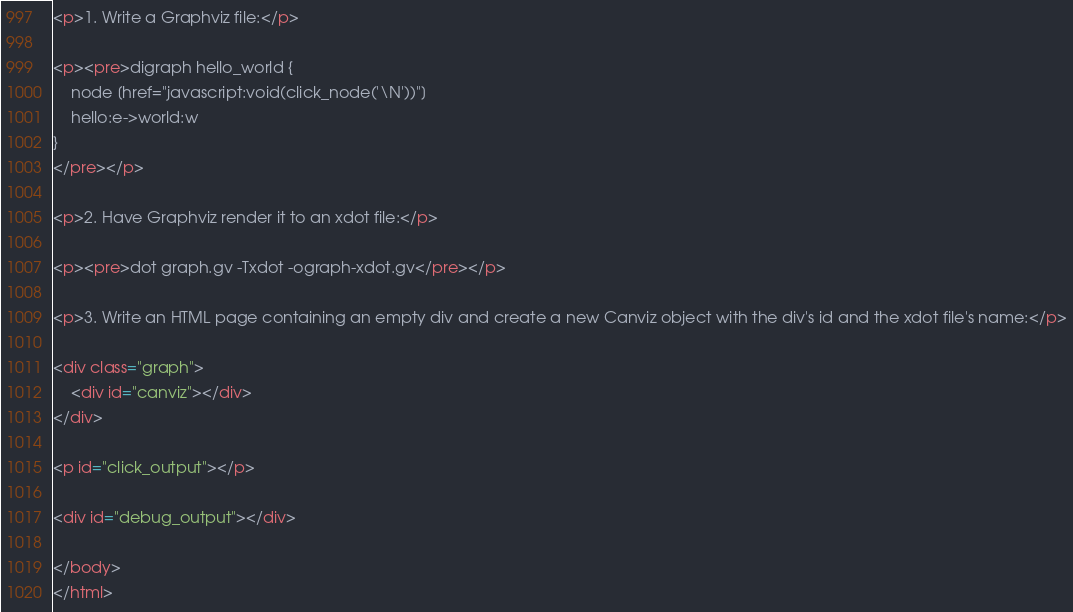Convert code to text. <code><loc_0><loc_0><loc_500><loc_500><_HTML_>
<p>1. Write a Graphviz file:</p>

<p><pre>digraph hello_world {
	node [href="javascript:void(click_node('\N'))"]
	hello:e->world:w
}
</pre></p>

<p>2. Have Graphviz render it to an xdot file:</p>

<p><pre>dot graph.gv -Txdot -ograph-xdot.gv</pre></p>

<p>3. Write an HTML page containing an empty div and create a new Canviz object with the div's id and the xdot file's name:</p>

<div class="graph">
	<div id="canviz"></div>
</div>

<p id="click_output"></p>

<div id="debug_output"></div>

</body>
</html>
</code> 